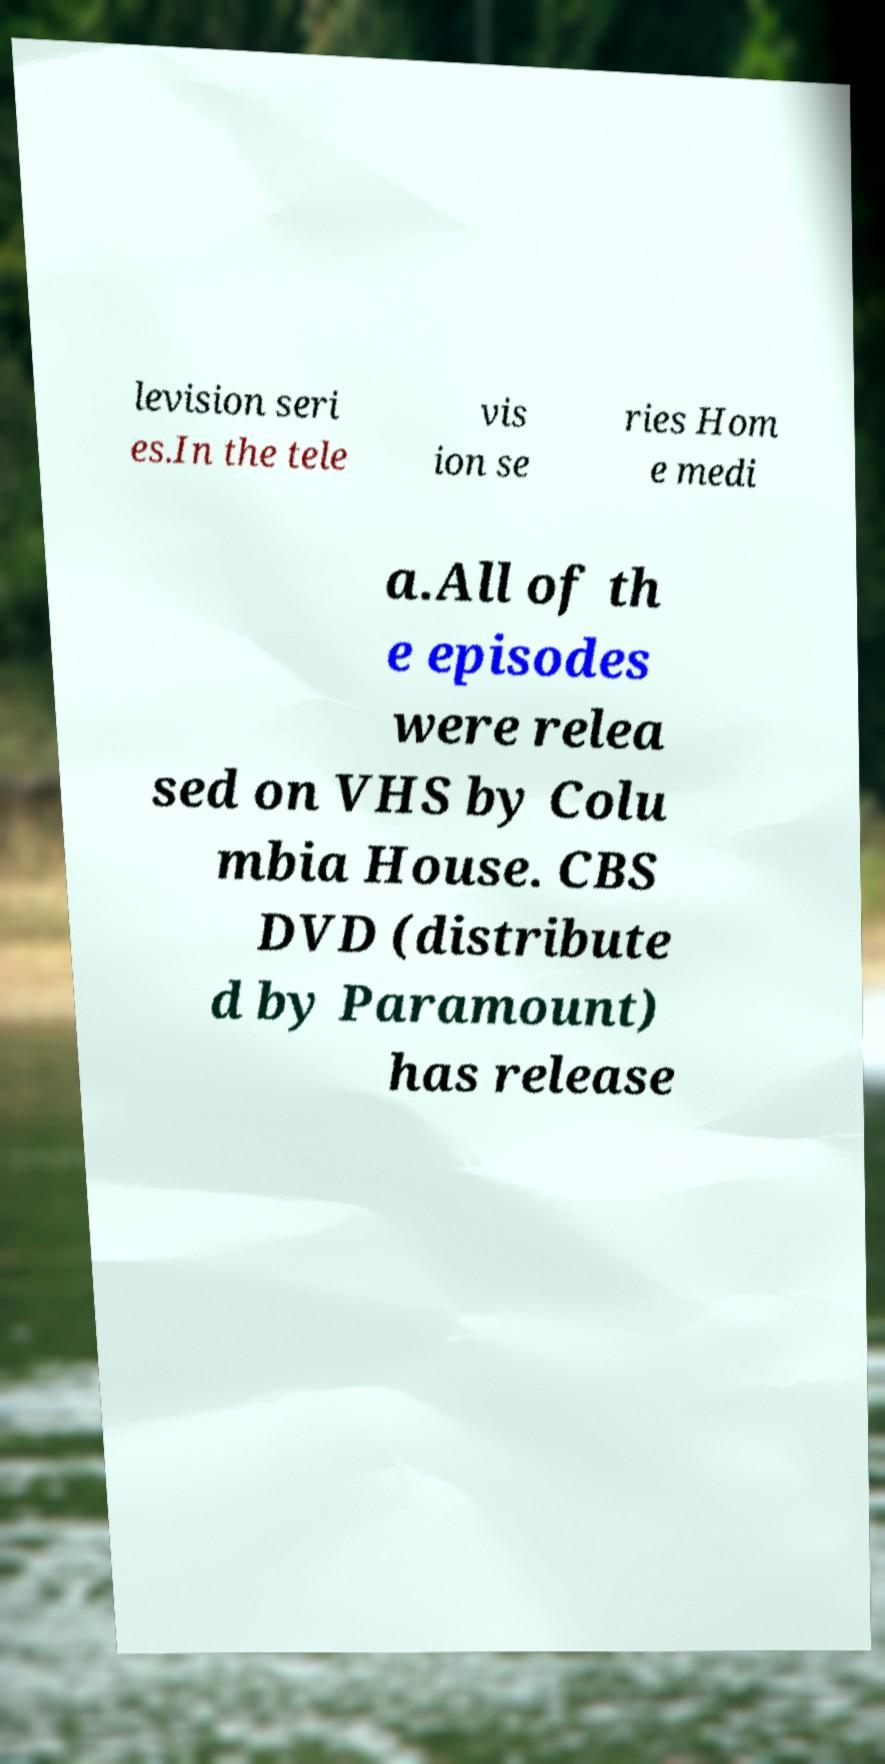Could you assist in decoding the text presented in this image and type it out clearly? levision seri es.In the tele vis ion se ries Hom e medi a.All of th e episodes were relea sed on VHS by Colu mbia House. CBS DVD (distribute d by Paramount) has release 